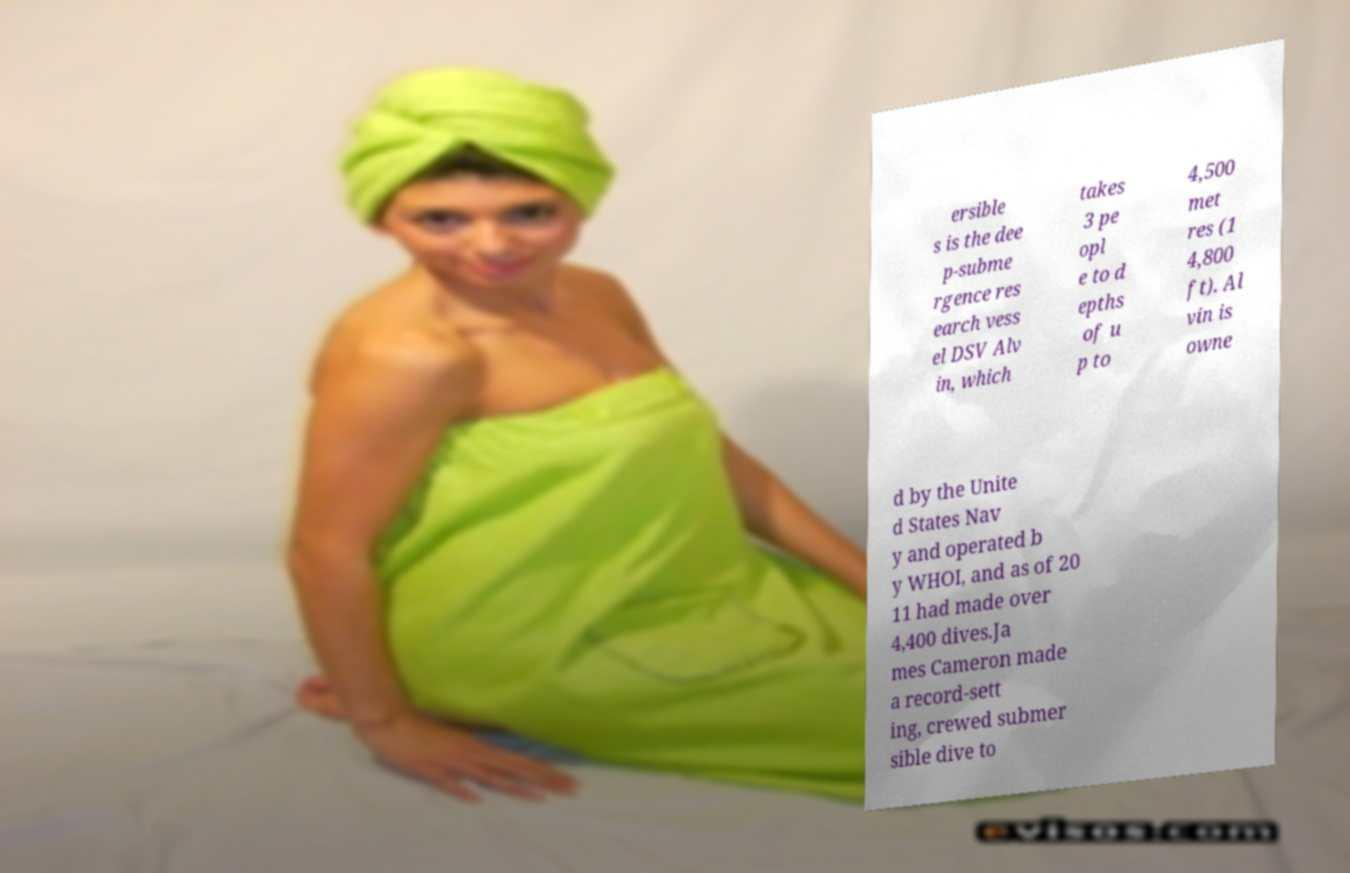Can you accurately transcribe the text from the provided image for me? ersible s is the dee p-subme rgence res earch vess el DSV Alv in, which takes 3 pe opl e to d epths of u p to 4,500 met res (1 4,800 ft). Al vin is owne d by the Unite d States Nav y and operated b y WHOI, and as of 20 11 had made over 4,400 dives.Ja mes Cameron made a record-sett ing, crewed submer sible dive to 